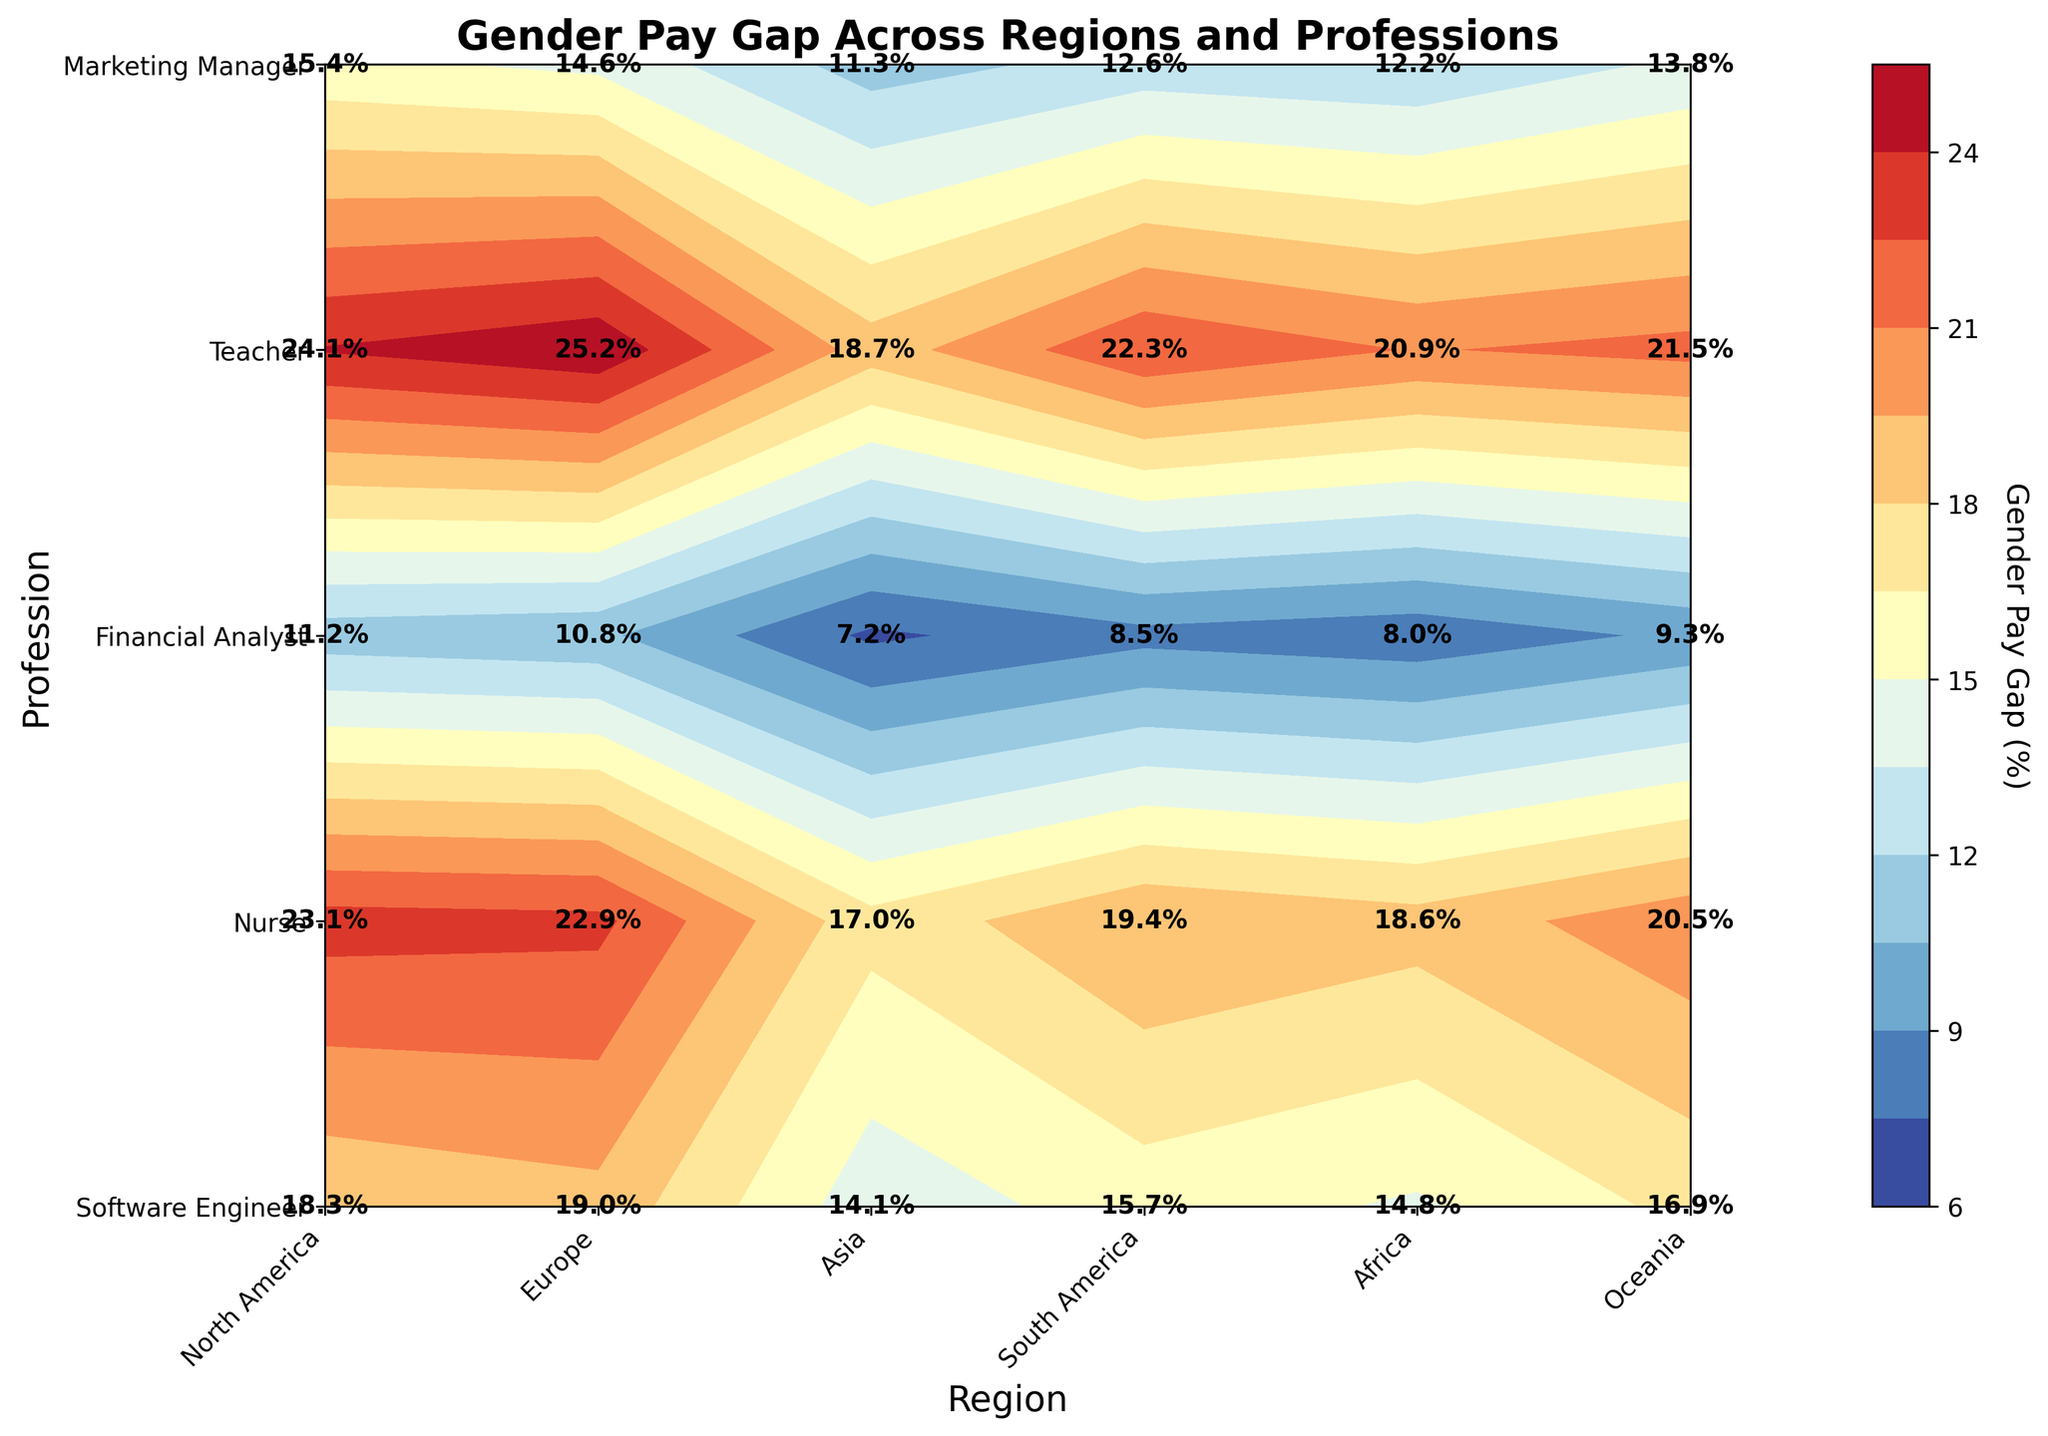What does the color legend represent in this plot? The color legend on the right-hand side represents the percentage of the gender pay gap, with a gradient from one color at a lower percentage to another color at a higher percentage. The exact values corresponding to different shades can be read directly from the legend.
Answer: The percentage of the gender pay gap Which profession in North America has the smallest gender pay gap? The contour plot uses annotations to indicate the exact values. By locating North America on the x-axis and identifying the annotated values, the Nurse profession shows the lowest value of 8.5%.
Answer: Nurse In which region do Software Engineers experience the highest gender pay gap? By comparing the values indicated for Software Engineers across the different regions, the highest value is 25.2% in Asia.
Answer: Asia How much greater is the gender pay gap for Financial Analysts in Africa compared to Europe? Locate the values for Financial Analysts in Africa and Europe, which are 18.3% and 14.1% respectively. Subtract Europe's value from Africa's: 18.3% - 14.1% = 4.2%.
Answer: 4.2% Which profession shows the most consistent gender pay gap across all regions? Consistency can be measured by minimal variation in percentages across regions. Checking the annotated values for each profession, the Teacher profession seems the most consistent with values ranging narrowly around 12.6% to 15.4%.
Answer: Teacher Across all regions, which profession in the Technology industry has the highest gender pay gap? By checking the 'Software Engineer' profession in the Technology industry across all regions, the highest value is 25.2% in Asia.
Answer: Software Engineer in Asia What is the average gender pay gap for Marketing Managers in South America and Oceania? Look at the annotated values for Marketing Managers in both regions: South America has 20.5% and Oceania has 18.6%. The average is calculated as (20.5% + 18.6%) / 2 = 19.55%.
Answer: 19.55% Compare the gender pay gap for Teachers in Europe and Africa. Which region is higher and by how much? From the contour plot, the annotated values for Teachers are 11.3% in Europe and 15.4% in Africa. Africa has a higher percentage by 15.4% - 11.3% = 4.1%.
Answer: Africa by 4.1% What overall trend can you infer from the plot regarding the gender pay gap in the healthcare industry across regions? By examining the annotated values for Nurses, which represent the healthcare industry, across all regions, it shows consistently lower percentages compared to other professions, with values ranging from 7.2% to 11.2%.
Answer: Consistently lower gender pay gap Identify the profession with the highest gender pay gap in Oceania and its value. By checking the annotated values specific to Oceania, the Software Engineer profession has the highest gender pay gap at 20.9%.
Answer: Software Engineer, 20.9% 